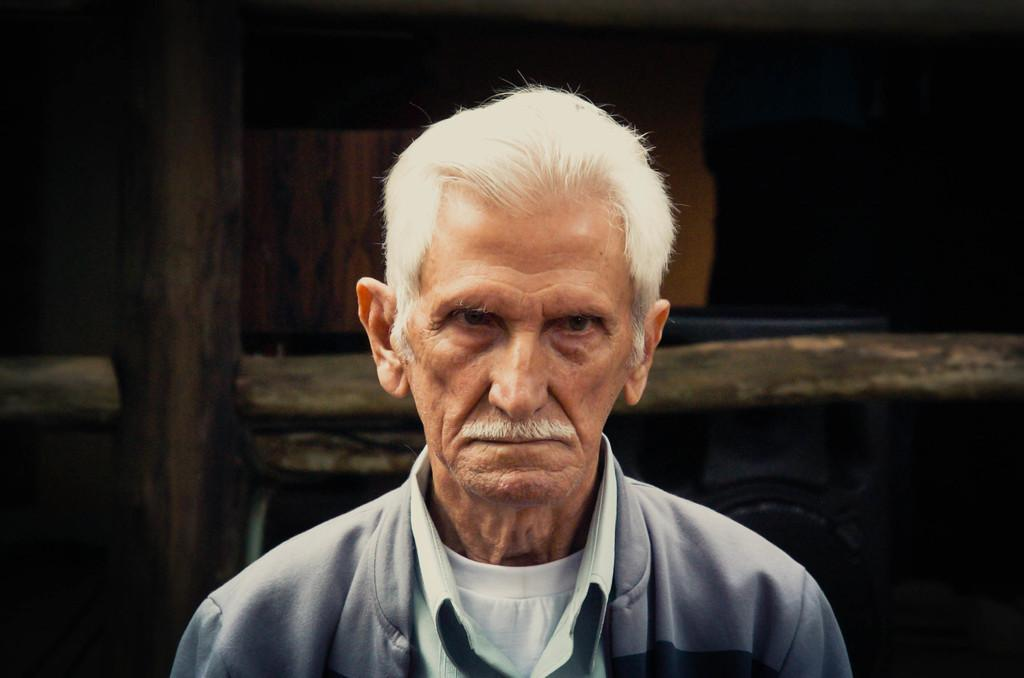What is the main subject of the image? There is a person in the image. Can you describe the background of the image? There are objects behind the person in the image. What type of stamp can be seen on the person's forehead in the image? There is no stamp visible on the person's forehead in the image. Can you describe the clouds in the image? There is no mention of clouds in the provided facts, so we cannot describe them in the image. 